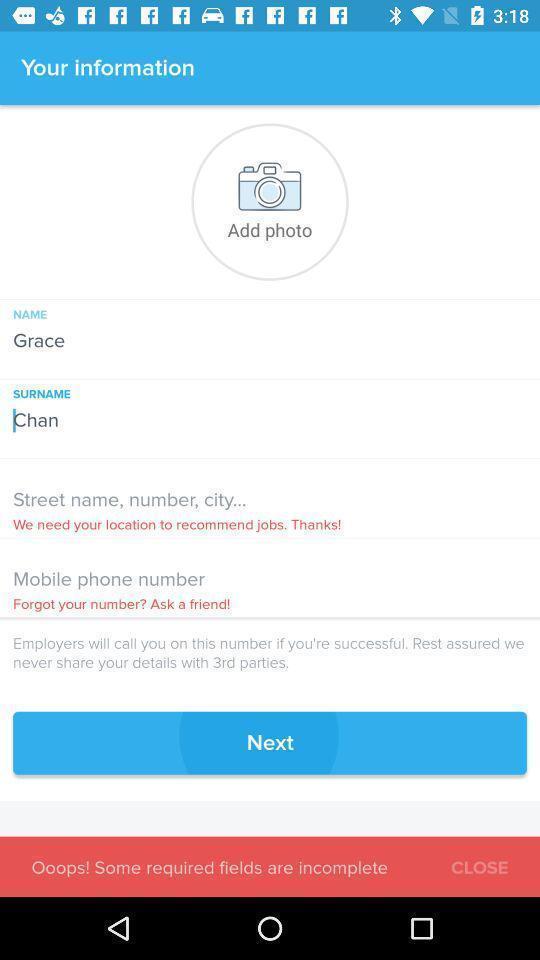What details can you identify in this image? User information page with address and number. 